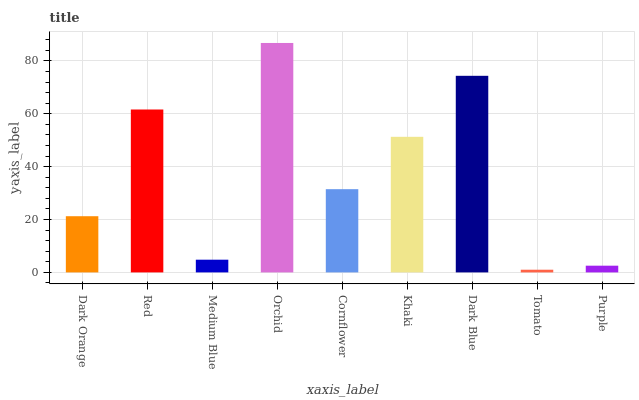Is Tomato the minimum?
Answer yes or no. Yes. Is Orchid the maximum?
Answer yes or no. Yes. Is Red the minimum?
Answer yes or no. No. Is Red the maximum?
Answer yes or no. No. Is Red greater than Dark Orange?
Answer yes or no. Yes. Is Dark Orange less than Red?
Answer yes or no. Yes. Is Dark Orange greater than Red?
Answer yes or no. No. Is Red less than Dark Orange?
Answer yes or no. No. Is Cornflower the high median?
Answer yes or no. Yes. Is Cornflower the low median?
Answer yes or no. Yes. Is Tomato the high median?
Answer yes or no. No. Is Purple the low median?
Answer yes or no. No. 